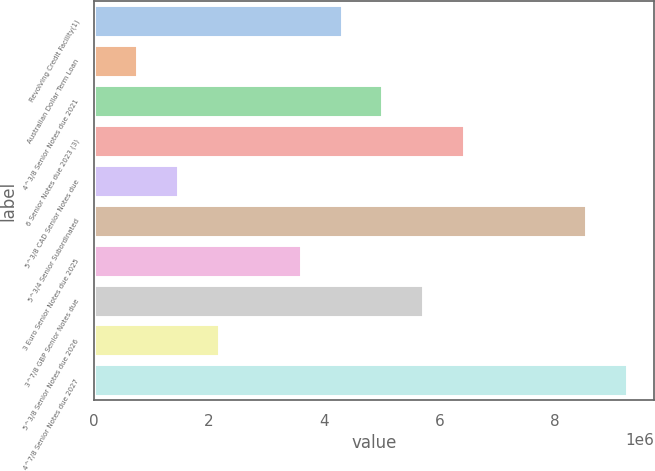Convert chart to OTSL. <chart><loc_0><loc_0><loc_500><loc_500><bar_chart><fcel>Revolving Credit Facility(1)<fcel>Australian Dollar Term Loan<fcel>4^3/8 Senior Notes due 2021<fcel>6 Senior Notes due 2023 (3)<fcel>5^3/8 CAD Senior Notes due<fcel>5^3/4 Senior Subordinated<fcel>3 Euro Senior Notes due 2025<fcel>3^7/8 GBP Senior Notes due<fcel>5^3/8 Senior Notes due 2026<fcel>4^7/8 Senior Notes due 2027<nl><fcel>4.29771e+06<fcel>757951<fcel>5.00566e+06<fcel>6.42156e+06<fcel>1.4659e+06<fcel>8.54541e+06<fcel>3.58976e+06<fcel>5.71361e+06<fcel>2.17385e+06<fcel>9.25336e+06<nl></chart> 